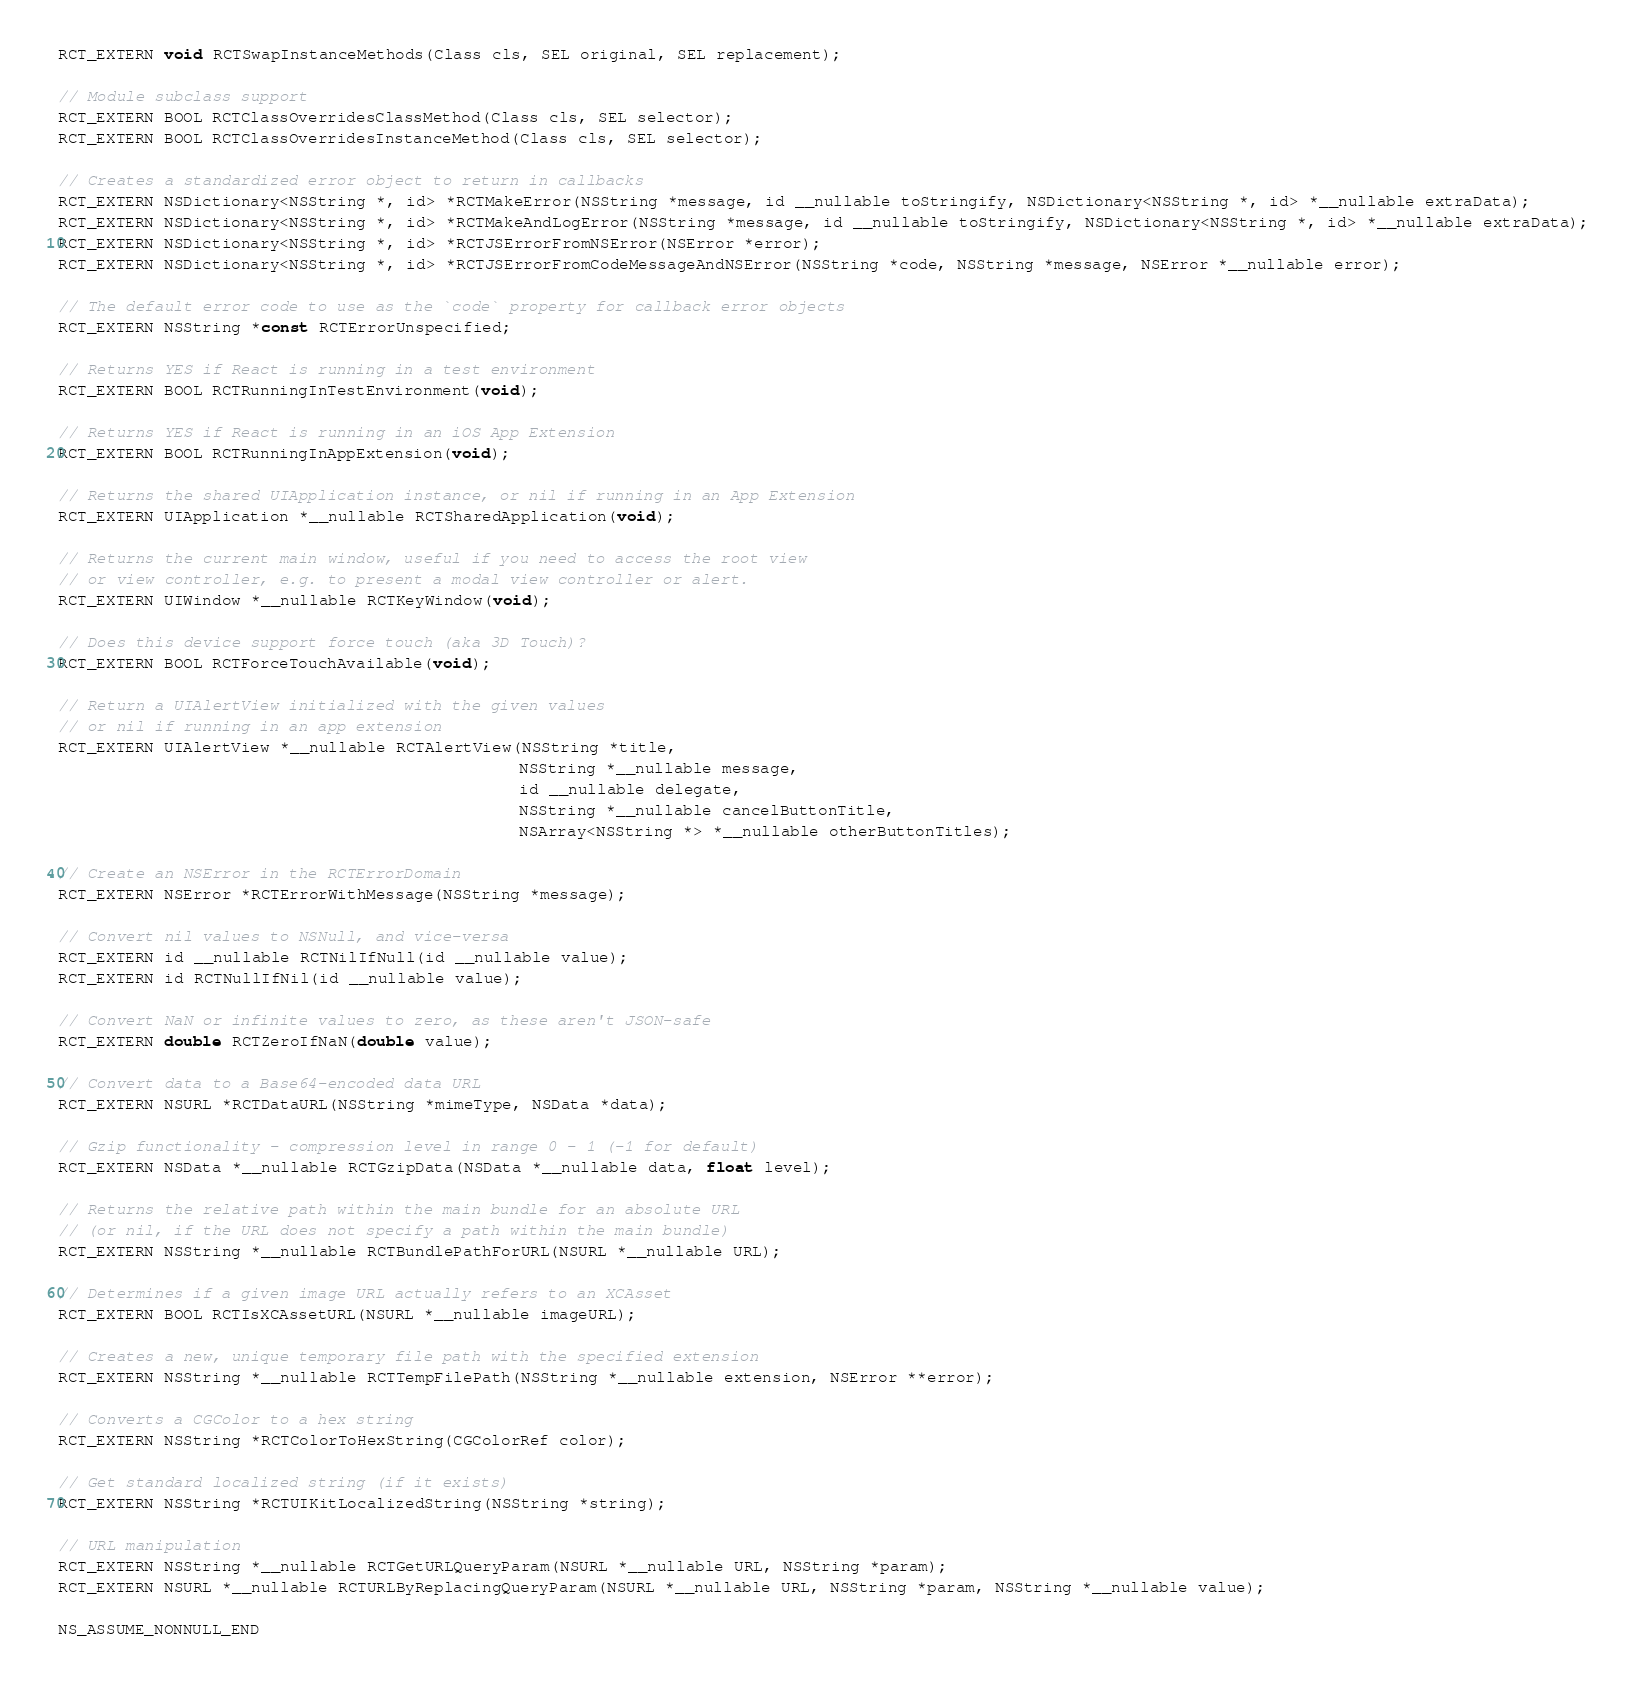Convert code to text. <code><loc_0><loc_0><loc_500><loc_500><_C_>RCT_EXTERN void RCTSwapInstanceMethods(Class cls, SEL original, SEL replacement);

// Module subclass support
RCT_EXTERN BOOL RCTClassOverridesClassMethod(Class cls, SEL selector);
RCT_EXTERN BOOL RCTClassOverridesInstanceMethod(Class cls, SEL selector);

// Creates a standardized error object to return in callbacks
RCT_EXTERN NSDictionary<NSString *, id> *RCTMakeError(NSString *message, id __nullable toStringify, NSDictionary<NSString *, id> *__nullable extraData);
RCT_EXTERN NSDictionary<NSString *, id> *RCTMakeAndLogError(NSString *message, id __nullable toStringify, NSDictionary<NSString *, id> *__nullable extraData);
RCT_EXTERN NSDictionary<NSString *, id> *RCTJSErrorFromNSError(NSError *error);
RCT_EXTERN NSDictionary<NSString *, id> *RCTJSErrorFromCodeMessageAndNSError(NSString *code, NSString *message, NSError *__nullable error);

// The default error code to use as the `code` property for callback error objects
RCT_EXTERN NSString *const RCTErrorUnspecified;

// Returns YES if React is running in a test environment
RCT_EXTERN BOOL RCTRunningInTestEnvironment(void);

// Returns YES if React is running in an iOS App Extension
RCT_EXTERN BOOL RCTRunningInAppExtension(void);

// Returns the shared UIApplication instance, or nil if running in an App Extension
RCT_EXTERN UIApplication *__nullable RCTSharedApplication(void);

// Returns the current main window, useful if you need to access the root view
// or view controller, e.g. to present a modal view controller or alert.
RCT_EXTERN UIWindow *__nullable RCTKeyWindow(void);

// Does this device support force touch (aka 3D Touch)?
RCT_EXTERN BOOL RCTForceTouchAvailable(void);

// Return a UIAlertView initialized with the given values
// or nil if running in an app extension
RCT_EXTERN UIAlertView *__nullable RCTAlertView(NSString *title,
                                                NSString *__nullable message,
                                                id __nullable delegate,
                                                NSString *__nullable cancelButtonTitle,
                                                NSArray<NSString *> *__nullable otherButtonTitles);

// Create an NSError in the RCTErrorDomain
RCT_EXTERN NSError *RCTErrorWithMessage(NSString *message);

// Convert nil values to NSNull, and vice-versa
RCT_EXTERN id __nullable RCTNilIfNull(id __nullable value);
RCT_EXTERN id RCTNullIfNil(id __nullable value);

// Convert NaN or infinite values to zero, as these aren't JSON-safe
RCT_EXTERN double RCTZeroIfNaN(double value);

// Convert data to a Base64-encoded data URL
RCT_EXTERN NSURL *RCTDataURL(NSString *mimeType, NSData *data);

// Gzip functionality - compression level in range 0 - 1 (-1 for default)
RCT_EXTERN NSData *__nullable RCTGzipData(NSData *__nullable data, float level);

// Returns the relative path within the main bundle for an absolute URL
// (or nil, if the URL does not specify a path within the main bundle)
RCT_EXTERN NSString *__nullable RCTBundlePathForURL(NSURL *__nullable URL);

// Determines if a given image URL actually refers to an XCAsset
RCT_EXTERN BOOL RCTIsXCAssetURL(NSURL *__nullable imageURL);

// Creates a new, unique temporary file path with the specified extension
RCT_EXTERN NSString *__nullable RCTTempFilePath(NSString *__nullable extension, NSError **error);

// Converts a CGColor to a hex string
RCT_EXTERN NSString *RCTColorToHexString(CGColorRef color);

// Get standard localized string (if it exists)
RCT_EXTERN NSString *RCTUIKitLocalizedString(NSString *string);

// URL manipulation
RCT_EXTERN NSString *__nullable RCTGetURLQueryParam(NSURL *__nullable URL, NSString *param);
RCT_EXTERN NSURL *__nullable RCTURLByReplacingQueryParam(NSURL *__nullable URL, NSString *param, NSString *__nullable value);

NS_ASSUME_NONNULL_END
</code> 